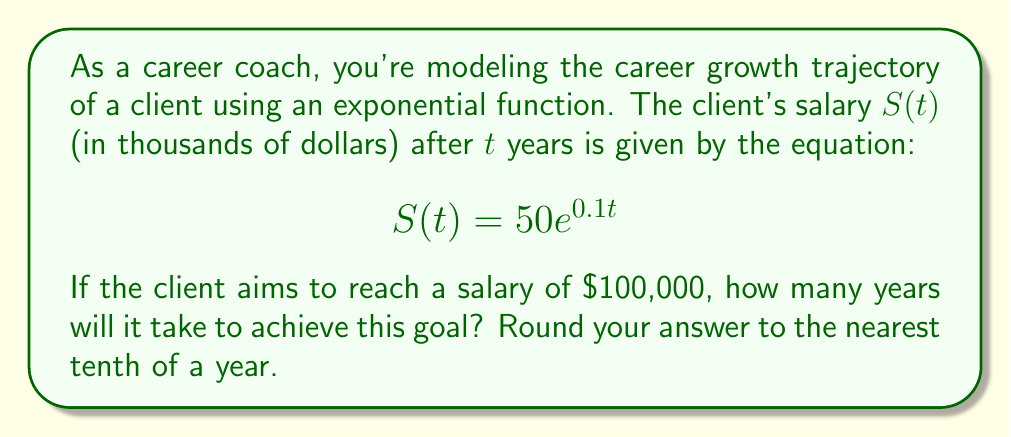Give your solution to this math problem. To solve this problem, we need to use the given exponential function and determine when the salary reaches $100,000. Let's approach this step-by-step:

1) The target salary is $100,000, which is 100 in terms of thousands of dollars.

2) We can set up the equation:
   $$100 = 50e^{0.1t}$$

3) Divide both sides by 50:
   $$2 = e^{0.1t}$$

4) Take the natural logarithm of both sides:
   $$\ln(2) = \ln(e^{0.1t})$$

5) Simplify the right side using the properties of logarithms:
   $$\ln(2) = 0.1t$$

6) Solve for $t$:
   $$t = \frac{\ln(2)}{0.1}$$

7) Calculate the value:
   $$t = \frac{0.693147...}{0.1} \approx 6.93147...$$

8) Rounding to the nearest tenth:
   $$t \approx 6.9 \text{ years}$$
Answer: 6.9 years 